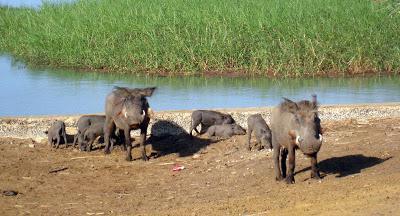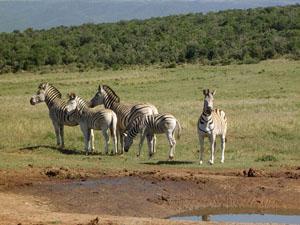The first image is the image on the left, the second image is the image on the right. For the images displayed, is the sentence "An image includes at least five zebra standing on grass behind a patch of dirt." factually correct? Answer yes or no. Yes. The first image is the image on the left, the second image is the image on the right. Assess this claim about the two images: "Some of the animals are near a watery area.". Correct or not? Answer yes or no. Yes. 